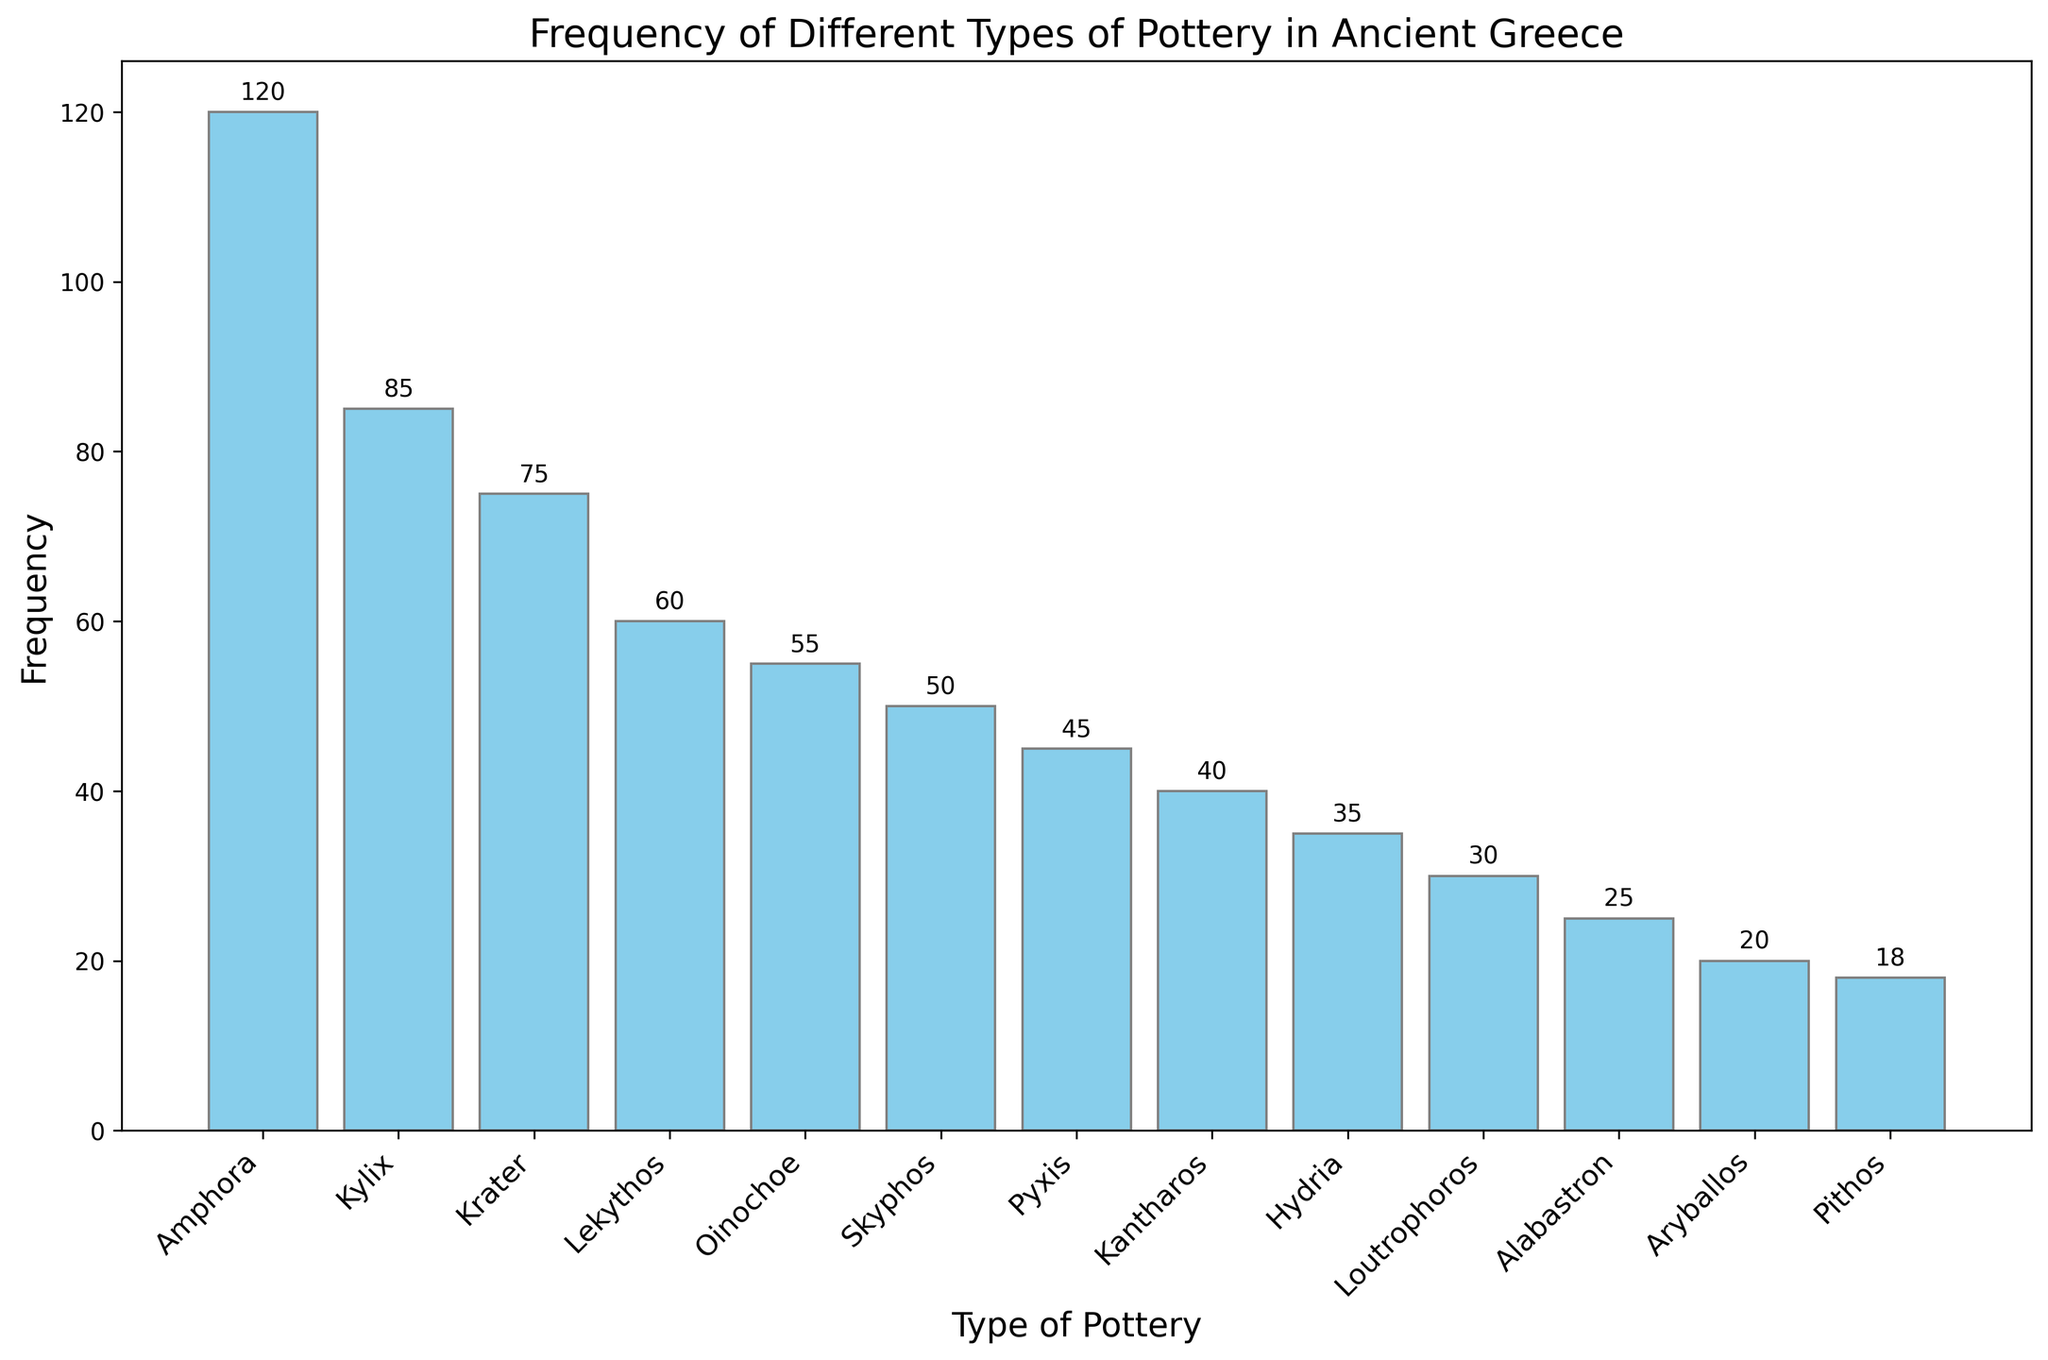Which type of pottery is the most frequently found in ancient Greece archaeological sites? To identify the most frequent type of pottery, we look for the tallest bar in the chart. The Amphora has the highest bar with a frequency of 120.
Answer: Amphora Which type of pottery is the least frequently found in ancient Greece archaeological sites? To find the least frequent type, we look for the shortest bar in the chart. The Pithos has the shortest bar with a frequency of 18.
Answer: Pithos What is the total frequency of Kylix, Krater, and Lekythos combined? First, find the frequencies of Kylix (85), Krater (75), and Lekythos (60) from the chart. Then, sum them up: 85 + 75 + 60 = 220.
Answer: 220 How many more Amphorae were found compared to Aryballos? Determine the frequencies for Amphora (120) and Aryballos (20) from the chart. Subtract the Aryballos frequency from the Amphora frequency: 120 - 20 = 100.
Answer: 100 Are there more Kylixes or Hydrias found, and by how many? The chart shows that the frequency of Kylixes is 85, and Hydrias is 35. Subtract the Hydrias frequency from the Kylixes: 85 - 35 = 50.
Answer: Kylixes, by 50 What is the average frequency of the top three most common types of pottery? Find the frequencies of the top three types: Amphora (120), Kylix (85), and Krater (75). Sum them up and divide by 3 to find the average: (120 + 85 + 75) / 3 = 280 / 3 ≈ 93.33.
Answer: 93.33 Which types of pottery have frequencies greater than 50? Identify the types from the chart where the bars extend beyond the 50 mark. They are Amphora (120), Kylix (85), Krater (75), Lekythos (60), and Oinochoe (55).
Answer: Amphora, Kylix, Krater, Lekythos, Oinochoe Are there more than twice as many Amphorae as there are Oinochoes? Determine the frequency of Amphora (120) and Oinochoe (55). Double the frequency of Oinochoe: 2 * 55 = 110. Compare with Amphora's frequency: 120 is greater than 110.
Answer: Yes What is the difference in frequency between the most common and the least common types of pottery? Find the frequencies of the most common (Amphora, 120) and the least common (Pithos, 18). Subtract Pithos frequency from Amphora: 120 - 18 = 102.
Answer: 102 